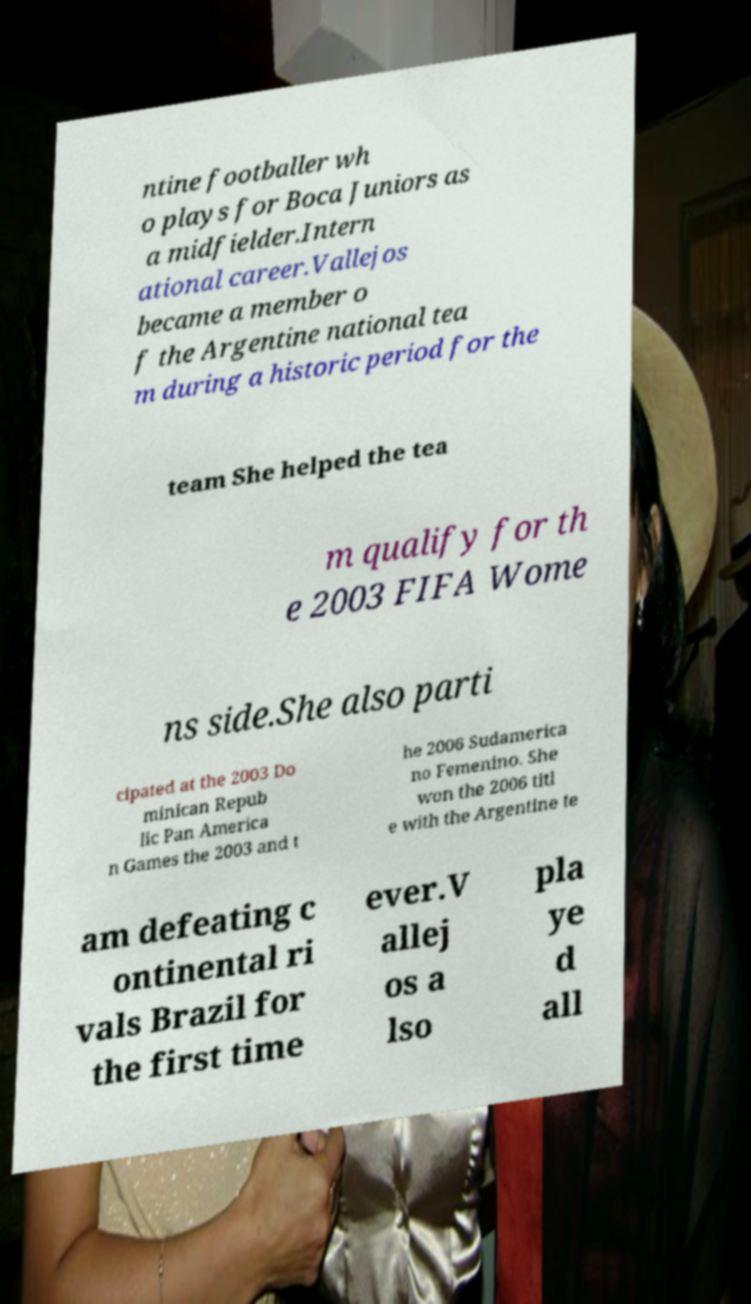Could you assist in decoding the text presented in this image and type it out clearly? ntine footballer wh o plays for Boca Juniors as a midfielder.Intern ational career.Vallejos became a member o f the Argentine national tea m during a historic period for the team She helped the tea m qualify for th e 2003 FIFA Wome ns side.She also parti cipated at the 2003 Do minican Repub lic Pan America n Games the 2003 and t he 2006 Sudamerica no Femenino. She won the 2006 titl e with the Argentine te am defeating c ontinental ri vals Brazil for the first time ever.V allej os a lso pla ye d all 